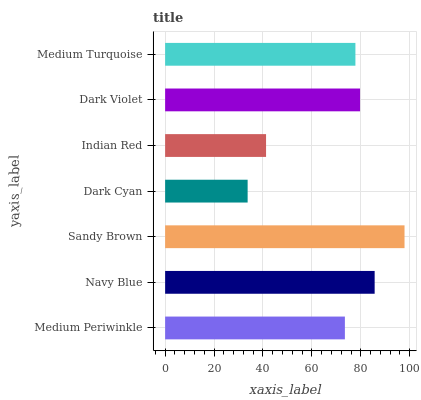Is Dark Cyan the minimum?
Answer yes or no. Yes. Is Sandy Brown the maximum?
Answer yes or no. Yes. Is Navy Blue the minimum?
Answer yes or no. No. Is Navy Blue the maximum?
Answer yes or no. No. Is Navy Blue greater than Medium Periwinkle?
Answer yes or no. Yes. Is Medium Periwinkle less than Navy Blue?
Answer yes or no. Yes. Is Medium Periwinkle greater than Navy Blue?
Answer yes or no. No. Is Navy Blue less than Medium Periwinkle?
Answer yes or no. No. Is Medium Turquoise the high median?
Answer yes or no. Yes. Is Medium Turquoise the low median?
Answer yes or no. Yes. Is Dark Cyan the high median?
Answer yes or no. No. Is Indian Red the low median?
Answer yes or no. No. 